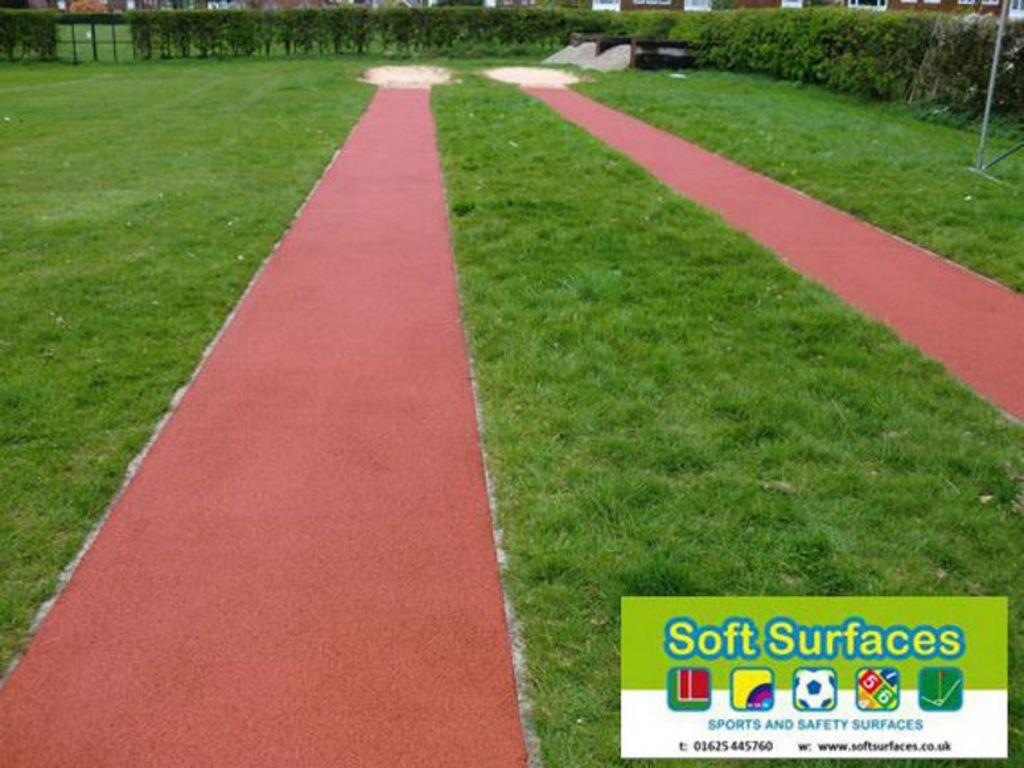What type of surface can be seen in the image? The ground is visible in the image. What type of vegetation is present in the image? There is grass and plants in the image. What structure can be seen in the image? There is a pole in the image. Is there any text or marking present in the image? Yes, a watermark is present in the image. What type of jewel is the person wearing in the image? There is no person or jewel present in the image. What color is the dress worn by the person in the image? There is no person or dress present in the image. 